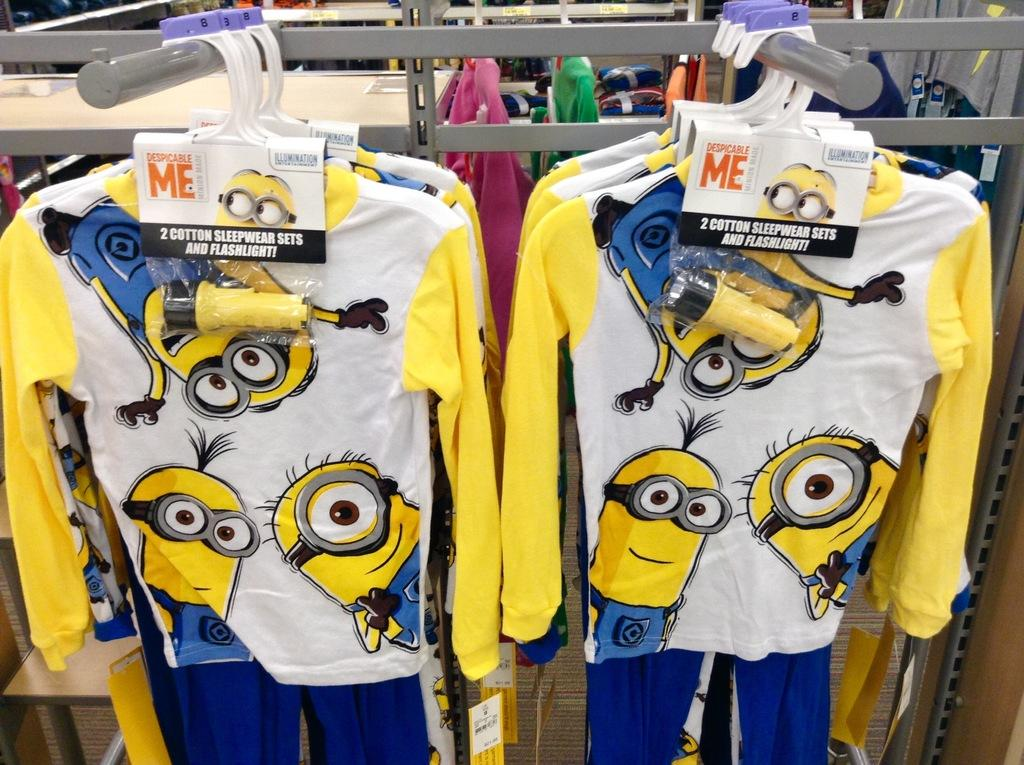<image>
Present a compact description of the photo's key features. Two outfits being put on sale with a sign that says Despicable Me. 